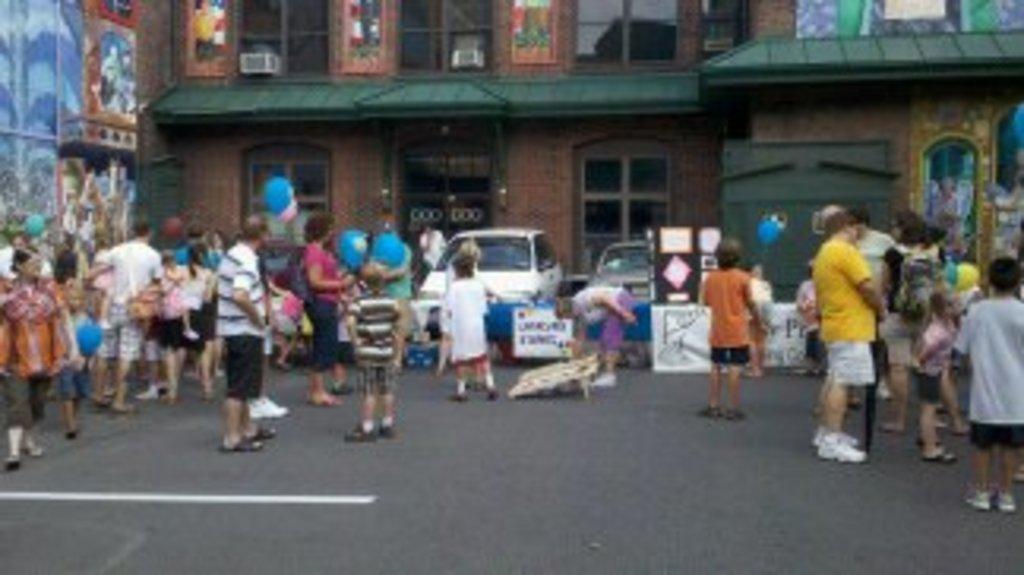In one or two sentences, can you explain what this image depicts? In this image I can see number of people are standing. I can also see few boards, few vehicles, buildings and on these boards I can see something is written. 